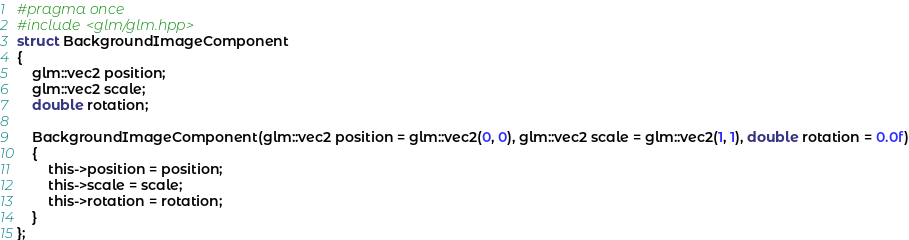Convert code to text. <code><loc_0><loc_0><loc_500><loc_500><_C_>#pragma once
#include <glm/glm.hpp>
struct BackgroundImageComponent
{
	glm::vec2 position;
	glm::vec2 scale;
	double rotation;

	BackgroundImageComponent(glm::vec2 position = glm::vec2(0, 0), glm::vec2 scale = glm::vec2(1, 1), double rotation = 0.0f)
	{
		this->position = position;
		this->scale = scale;
		this->rotation = rotation;
	}
};</code> 